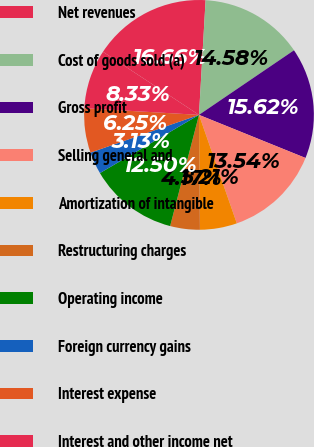<chart> <loc_0><loc_0><loc_500><loc_500><pie_chart><fcel>Net revenues<fcel>Cost of goods sold (a)<fcel>Gross profit<fcel>Selling general and<fcel>Amortization of intangible<fcel>Restructuring charges<fcel>Operating income<fcel>Foreign currency gains<fcel>Interest expense<fcel>Interest and other income net<nl><fcel>16.66%<fcel>14.58%<fcel>15.62%<fcel>13.54%<fcel>5.21%<fcel>4.17%<fcel>12.5%<fcel>3.13%<fcel>6.25%<fcel>8.33%<nl></chart> 